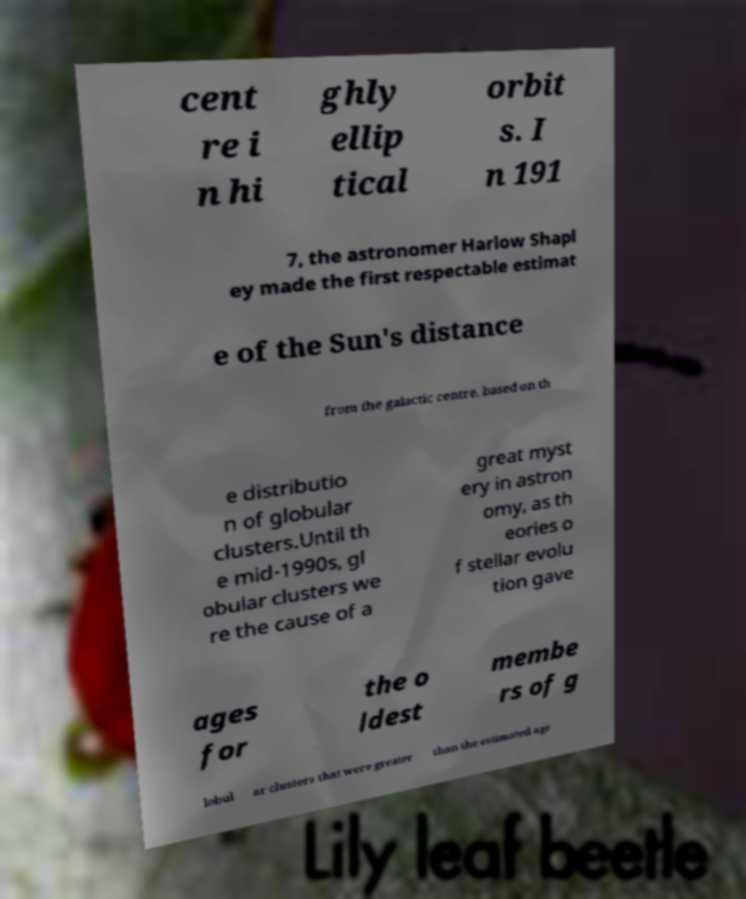Please read and relay the text visible in this image. What does it say? cent re i n hi ghly ellip tical orbit s. I n 191 7, the astronomer Harlow Shapl ey made the first respectable estimat e of the Sun's distance from the galactic centre, based on th e distributio n of globular clusters.Until th e mid-1990s, gl obular clusters we re the cause of a great myst ery in astron omy, as th eories o f stellar evolu tion gave ages for the o ldest membe rs of g lobul ar clusters that were greater than the estimated age 